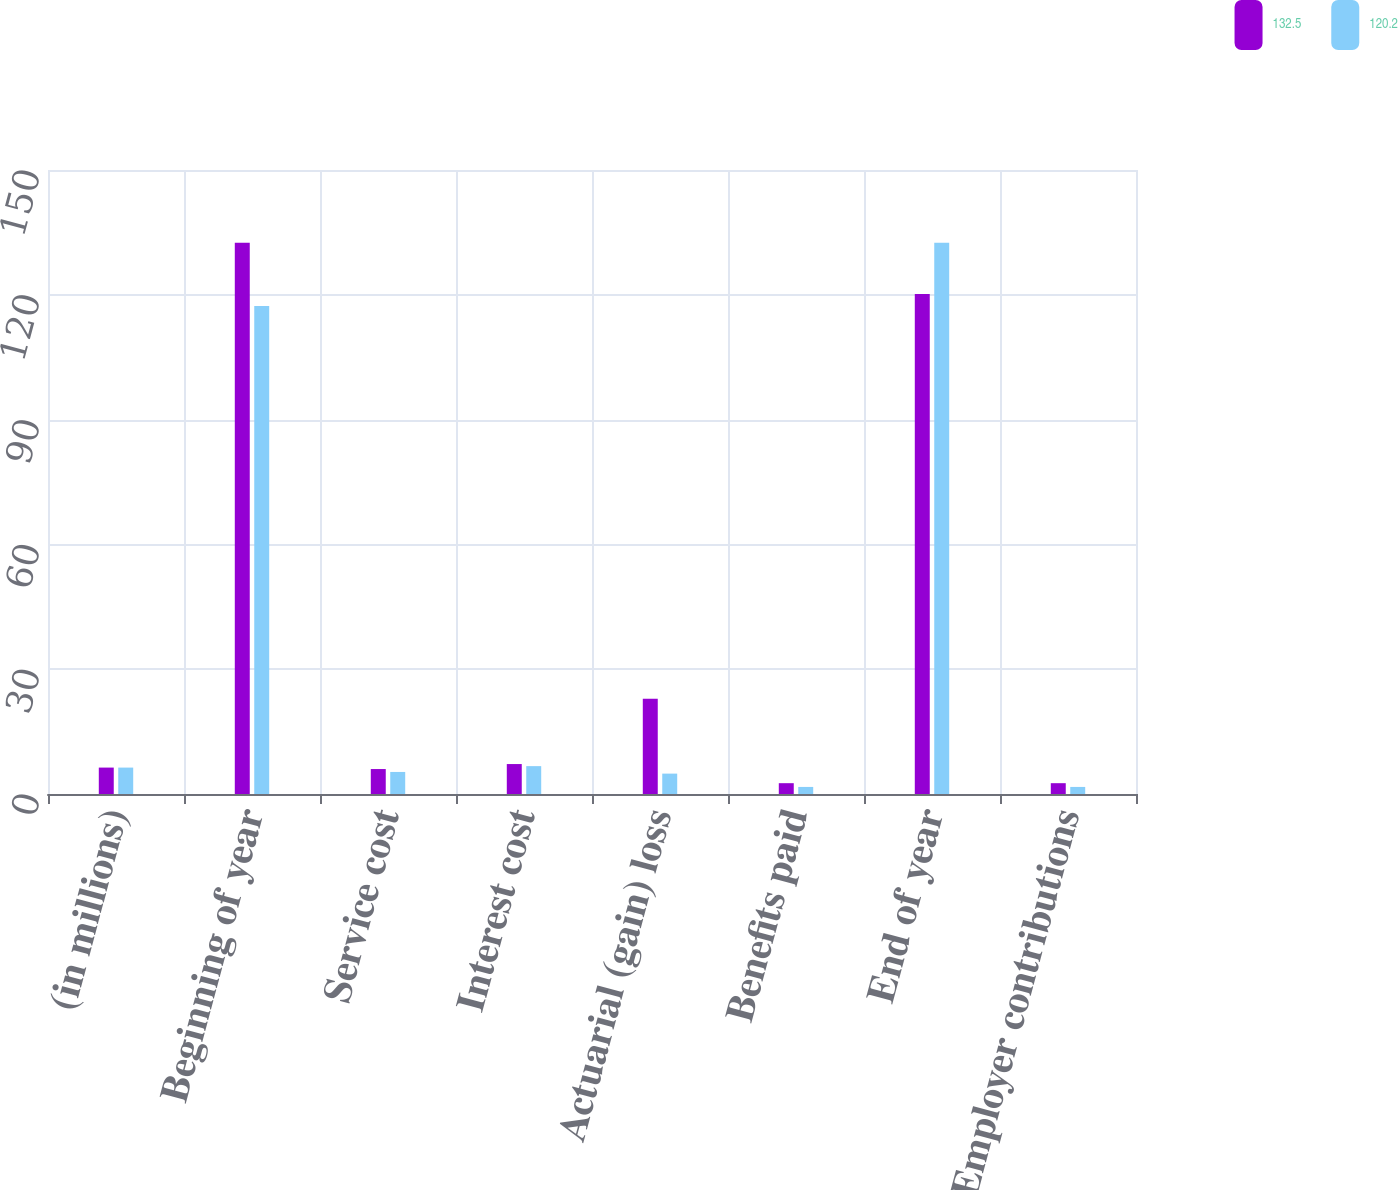<chart> <loc_0><loc_0><loc_500><loc_500><stacked_bar_chart><ecel><fcel>(in millions)<fcel>Beginning of year<fcel>Service cost<fcel>Interest cost<fcel>Actuarial (gain) loss<fcel>Benefits paid<fcel>End of year<fcel>Employer contributions<nl><fcel>132.5<fcel>6.35<fcel>132.5<fcel>6<fcel>7.2<fcel>22.9<fcel>2.6<fcel>120.2<fcel>2.6<nl><fcel>120.2<fcel>6.35<fcel>117.3<fcel>5.3<fcel>6.7<fcel>4.9<fcel>1.7<fcel>132.5<fcel>1.7<nl></chart> 